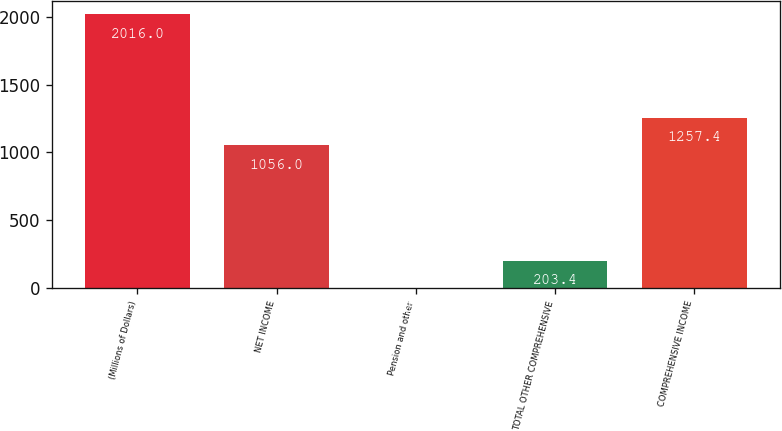Convert chart to OTSL. <chart><loc_0><loc_0><loc_500><loc_500><bar_chart><fcel>(Millions of Dollars)<fcel>NET INCOME<fcel>Pension and other<fcel>TOTAL OTHER COMPREHENSIVE<fcel>COMPREHENSIVE INCOME<nl><fcel>2016<fcel>1056<fcel>2<fcel>203.4<fcel>1257.4<nl></chart> 